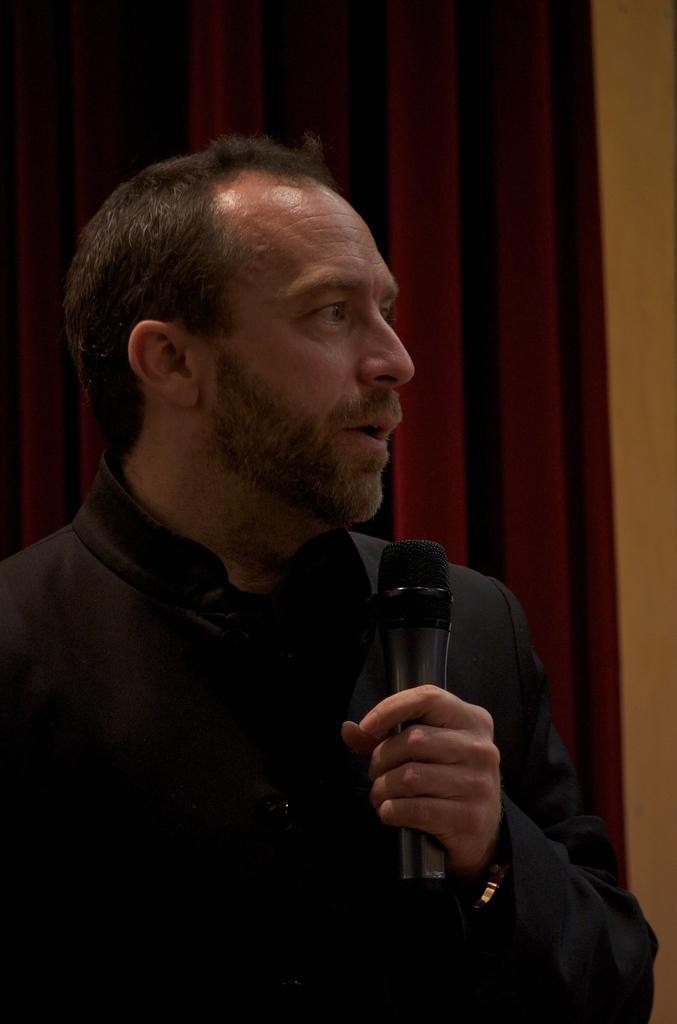Describe this image in one or two sentences. This picture shows a man, holding a mic in her, in his hand. In the background, there is a red curtain and a wall here. 